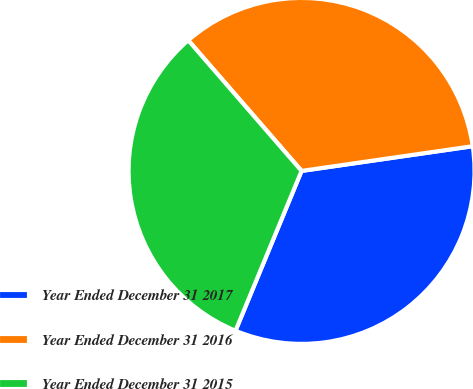<chart> <loc_0><loc_0><loc_500><loc_500><pie_chart><fcel>Year Ended December 31 2017<fcel>Year Ended December 31 2016<fcel>Year Ended December 31 2015<nl><fcel>33.52%<fcel>34.09%<fcel>32.39%<nl></chart> 